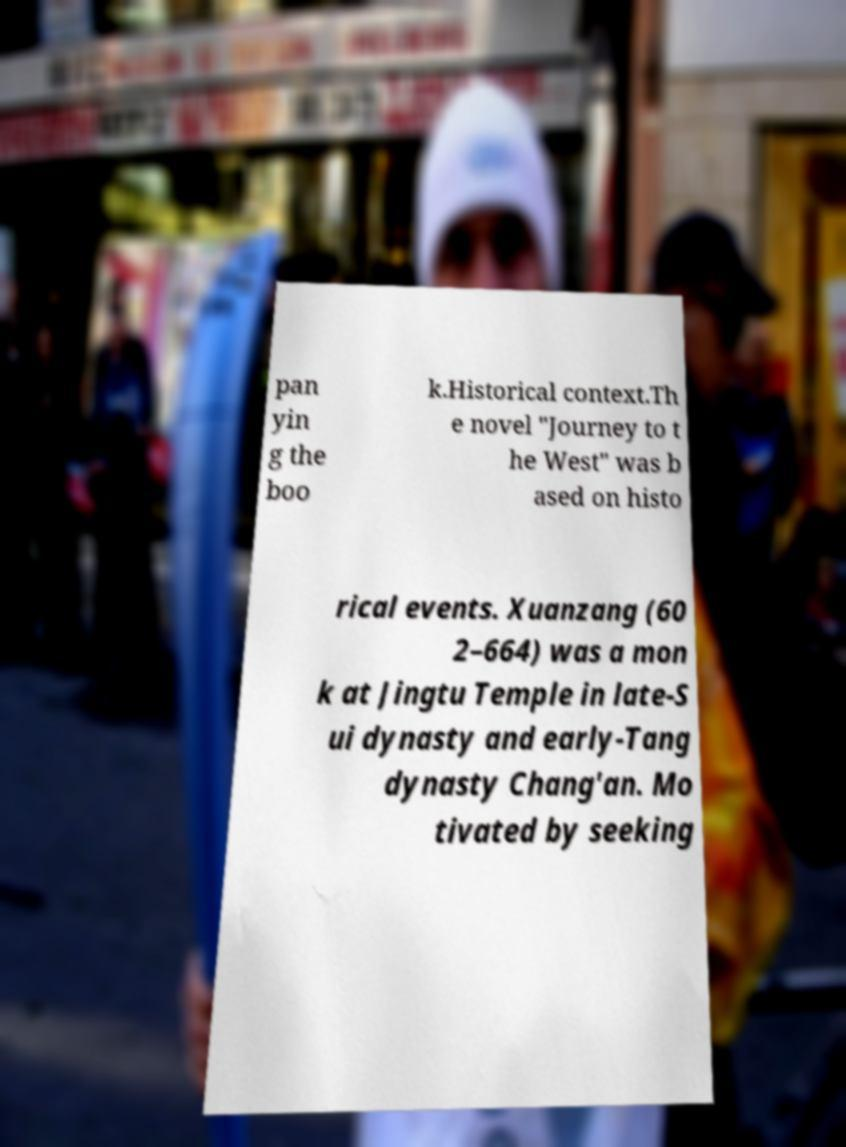Please identify and transcribe the text found in this image. pan yin g the boo k.Historical context.Th e novel "Journey to t he West" was b ased on histo rical events. Xuanzang (60 2–664) was a mon k at Jingtu Temple in late-S ui dynasty and early-Tang dynasty Chang'an. Mo tivated by seeking 